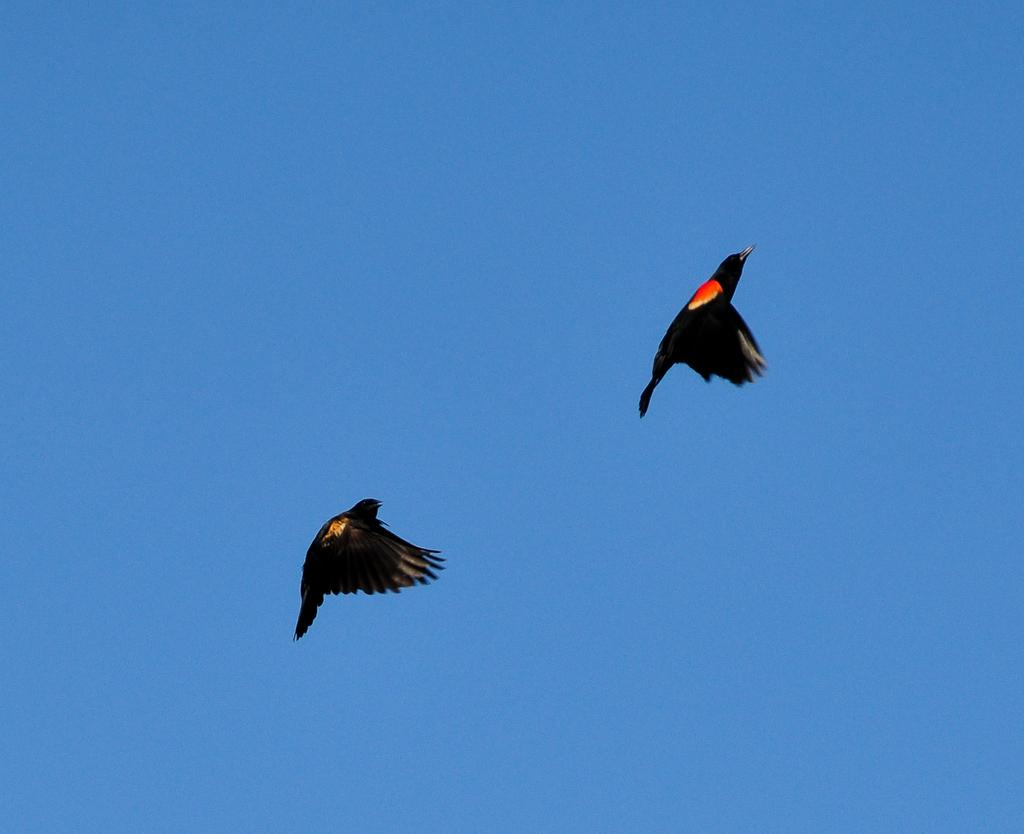What animals are present in the image? There are two black birds in the image. What are the birds doing in the image? The birds are flying in the sky. What is the color of the sky in the image? The sky is black in color. What type of hospital can be seen in the image? There is no hospital present in the image; it features two black birds flying in a black sky. Can you tell me the color of the veins in the birds' wings? There is no information about the birds' veins or their color in the image. 